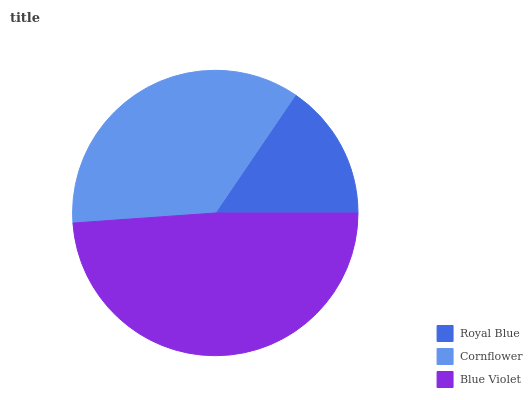Is Royal Blue the minimum?
Answer yes or no. Yes. Is Blue Violet the maximum?
Answer yes or no. Yes. Is Cornflower the minimum?
Answer yes or no. No. Is Cornflower the maximum?
Answer yes or no. No. Is Cornflower greater than Royal Blue?
Answer yes or no. Yes. Is Royal Blue less than Cornflower?
Answer yes or no. Yes. Is Royal Blue greater than Cornflower?
Answer yes or no. No. Is Cornflower less than Royal Blue?
Answer yes or no. No. Is Cornflower the high median?
Answer yes or no. Yes. Is Cornflower the low median?
Answer yes or no. Yes. Is Royal Blue the high median?
Answer yes or no. No. Is Blue Violet the low median?
Answer yes or no. No. 